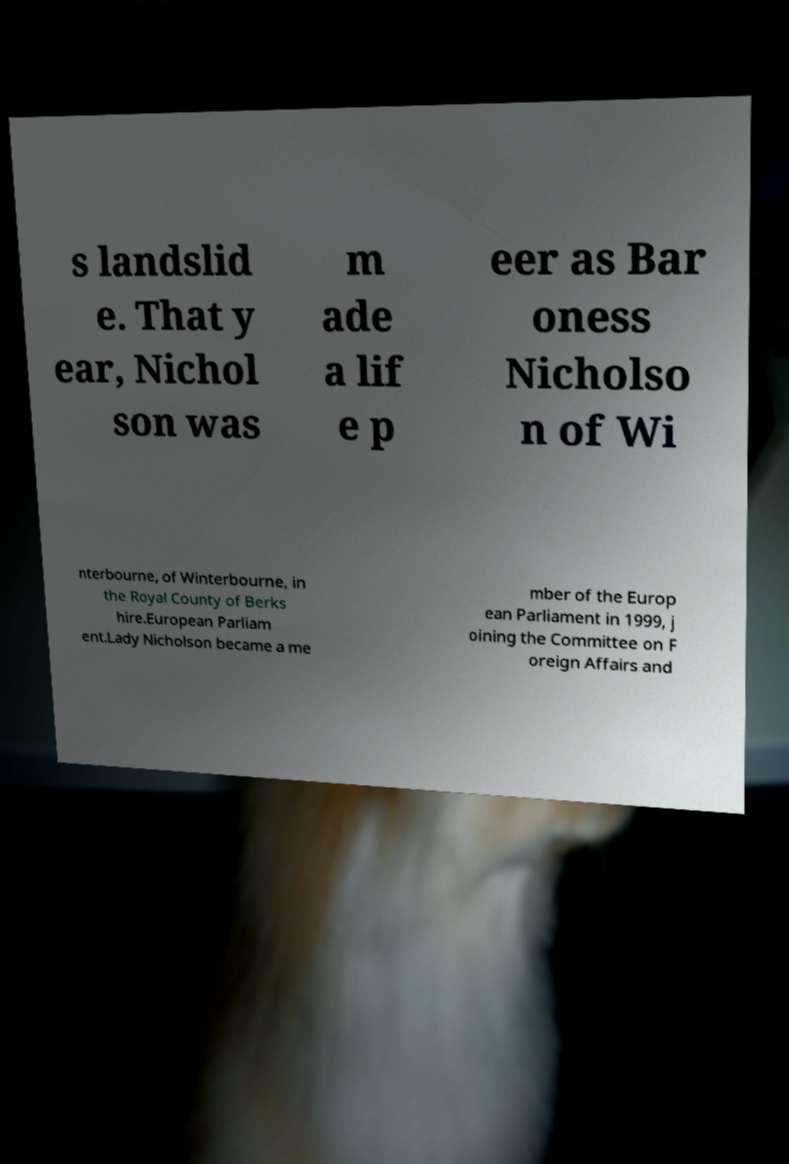There's text embedded in this image that I need extracted. Can you transcribe it verbatim? s landslid e. That y ear, Nichol son was m ade a lif e p eer as Bar oness Nicholso n of Wi nterbourne, of Winterbourne, in the Royal County of Berks hire.European Parliam ent.Lady Nicholson became a me mber of the Europ ean Parliament in 1999, j oining the Committee on F oreign Affairs and 